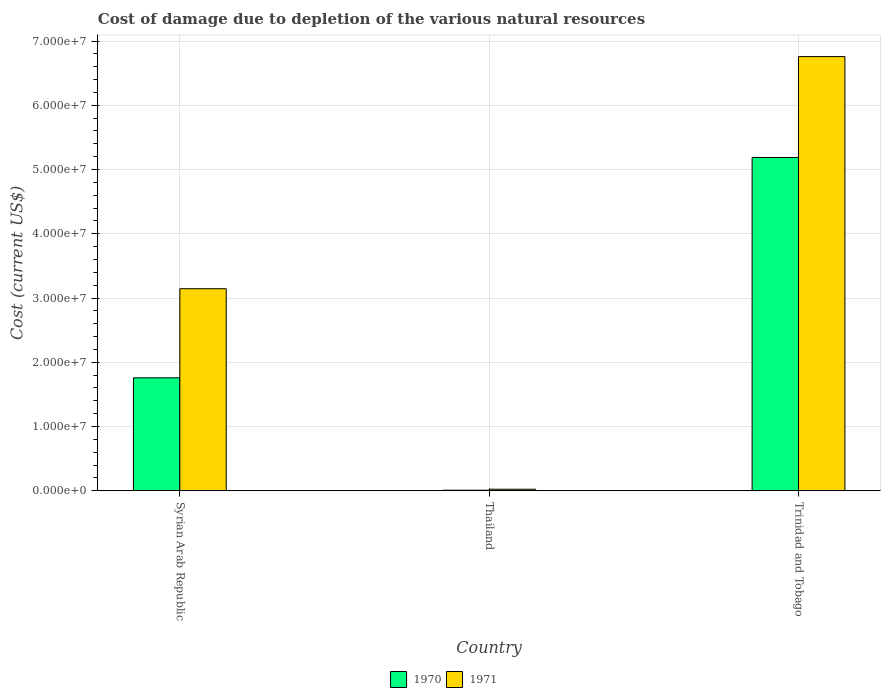How many groups of bars are there?
Your response must be concise. 3. Are the number of bars per tick equal to the number of legend labels?
Your answer should be very brief. Yes. Are the number of bars on each tick of the X-axis equal?
Make the answer very short. Yes. How many bars are there on the 3rd tick from the left?
Provide a short and direct response. 2. What is the label of the 3rd group of bars from the left?
Your answer should be very brief. Trinidad and Tobago. What is the cost of damage caused due to the depletion of various natural resources in 1971 in Syrian Arab Republic?
Offer a terse response. 3.14e+07. Across all countries, what is the maximum cost of damage caused due to the depletion of various natural resources in 1970?
Your response must be concise. 5.19e+07. Across all countries, what is the minimum cost of damage caused due to the depletion of various natural resources in 1970?
Provide a succinct answer. 9.00e+04. In which country was the cost of damage caused due to the depletion of various natural resources in 1970 maximum?
Keep it short and to the point. Trinidad and Tobago. In which country was the cost of damage caused due to the depletion of various natural resources in 1971 minimum?
Your response must be concise. Thailand. What is the total cost of damage caused due to the depletion of various natural resources in 1970 in the graph?
Keep it short and to the point. 6.96e+07. What is the difference between the cost of damage caused due to the depletion of various natural resources in 1970 in Syrian Arab Republic and that in Thailand?
Give a very brief answer. 1.75e+07. What is the difference between the cost of damage caused due to the depletion of various natural resources in 1970 in Syrian Arab Republic and the cost of damage caused due to the depletion of various natural resources in 1971 in Thailand?
Ensure brevity in your answer.  1.73e+07. What is the average cost of damage caused due to the depletion of various natural resources in 1970 per country?
Your answer should be compact. 2.32e+07. What is the difference between the cost of damage caused due to the depletion of various natural resources of/in 1970 and cost of damage caused due to the depletion of various natural resources of/in 1971 in Syrian Arab Republic?
Give a very brief answer. -1.39e+07. What is the ratio of the cost of damage caused due to the depletion of various natural resources in 1971 in Syrian Arab Republic to that in Thailand?
Ensure brevity in your answer.  129.33. What is the difference between the highest and the second highest cost of damage caused due to the depletion of various natural resources in 1971?
Offer a very short reply. -3.12e+07. What is the difference between the highest and the lowest cost of damage caused due to the depletion of various natural resources in 1970?
Provide a succinct answer. 5.18e+07. In how many countries, is the cost of damage caused due to the depletion of various natural resources in 1971 greater than the average cost of damage caused due to the depletion of various natural resources in 1971 taken over all countries?
Your answer should be very brief. 1. What does the 1st bar from the left in Thailand represents?
Your answer should be very brief. 1970. What does the 1st bar from the right in Thailand represents?
Provide a succinct answer. 1971. How many bars are there?
Offer a very short reply. 6. Are all the bars in the graph horizontal?
Provide a short and direct response. No. How many countries are there in the graph?
Your response must be concise. 3. What is the difference between two consecutive major ticks on the Y-axis?
Offer a very short reply. 1.00e+07. Are the values on the major ticks of Y-axis written in scientific E-notation?
Keep it short and to the point. Yes. Does the graph contain any zero values?
Provide a short and direct response. No. Does the graph contain grids?
Provide a short and direct response. Yes. Where does the legend appear in the graph?
Keep it short and to the point. Bottom center. How many legend labels are there?
Your answer should be very brief. 2. What is the title of the graph?
Make the answer very short. Cost of damage due to depletion of the various natural resources. Does "1999" appear as one of the legend labels in the graph?
Offer a very short reply. No. What is the label or title of the Y-axis?
Make the answer very short. Cost (current US$). What is the Cost (current US$) in 1970 in Syrian Arab Republic?
Offer a terse response. 1.76e+07. What is the Cost (current US$) in 1971 in Syrian Arab Republic?
Offer a terse response. 3.14e+07. What is the Cost (current US$) in 1970 in Thailand?
Your answer should be very brief. 9.00e+04. What is the Cost (current US$) in 1971 in Thailand?
Provide a short and direct response. 2.43e+05. What is the Cost (current US$) in 1970 in Trinidad and Tobago?
Provide a succinct answer. 5.19e+07. What is the Cost (current US$) in 1971 in Trinidad and Tobago?
Give a very brief answer. 6.76e+07. Across all countries, what is the maximum Cost (current US$) in 1970?
Provide a short and direct response. 5.19e+07. Across all countries, what is the maximum Cost (current US$) in 1971?
Make the answer very short. 6.76e+07. Across all countries, what is the minimum Cost (current US$) of 1970?
Provide a succinct answer. 9.00e+04. Across all countries, what is the minimum Cost (current US$) of 1971?
Offer a very short reply. 2.43e+05. What is the total Cost (current US$) of 1970 in the graph?
Give a very brief answer. 6.96e+07. What is the total Cost (current US$) in 1971 in the graph?
Your answer should be very brief. 9.93e+07. What is the difference between the Cost (current US$) of 1970 in Syrian Arab Republic and that in Thailand?
Give a very brief answer. 1.75e+07. What is the difference between the Cost (current US$) of 1971 in Syrian Arab Republic and that in Thailand?
Give a very brief answer. 3.12e+07. What is the difference between the Cost (current US$) of 1970 in Syrian Arab Republic and that in Trinidad and Tobago?
Offer a terse response. -3.43e+07. What is the difference between the Cost (current US$) of 1971 in Syrian Arab Republic and that in Trinidad and Tobago?
Offer a terse response. -3.61e+07. What is the difference between the Cost (current US$) in 1970 in Thailand and that in Trinidad and Tobago?
Ensure brevity in your answer.  -5.18e+07. What is the difference between the Cost (current US$) in 1971 in Thailand and that in Trinidad and Tobago?
Your answer should be compact. -6.73e+07. What is the difference between the Cost (current US$) in 1970 in Syrian Arab Republic and the Cost (current US$) in 1971 in Thailand?
Provide a succinct answer. 1.73e+07. What is the difference between the Cost (current US$) of 1970 in Syrian Arab Republic and the Cost (current US$) of 1971 in Trinidad and Tobago?
Your answer should be compact. -5.00e+07. What is the difference between the Cost (current US$) of 1970 in Thailand and the Cost (current US$) of 1971 in Trinidad and Tobago?
Make the answer very short. -6.75e+07. What is the average Cost (current US$) of 1970 per country?
Your answer should be compact. 2.32e+07. What is the average Cost (current US$) of 1971 per country?
Ensure brevity in your answer.  3.31e+07. What is the difference between the Cost (current US$) of 1970 and Cost (current US$) of 1971 in Syrian Arab Republic?
Offer a very short reply. -1.39e+07. What is the difference between the Cost (current US$) of 1970 and Cost (current US$) of 1971 in Thailand?
Provide a short and direct response. -1.53e+05. What is the difference between the Cost (current US$) of 1970 and Cost (current US$) of 1971 in Trinidad and Tobago?
Provide a short and direct response. -1.57e+07. What is the ratio of the Cost (current US$) of 1970 in Syrian Arab Republic to that in Thailand?
Provide a short and direct response. 195.44. What is the ratio of the Cost (current US$) in 1971 in Syrian Arab Republic to that in Thailand?
Your response must be concise. 129.33. What is the ratio of the Cost (current US$) of 1970 in Syrian Arab Republic to that in Trinidad and Tobago?
Provide a short and direct response. 0.34. What is the ratio of the Cost (current US$) in 1971 in Syrian Arab Republic to that in Trinidad and Tobago?
Make the answer very short. 0.47. What is the ratio of the Cost (current US$) of 1970 in Thailand to that in Trinidad and Tobago?
Ensure brevity in your answer.  0. What is the ratio of the Cost (current US$) of 1971 in Thailand to that in Trinidad and Tobago?
Give a very brief answer. 0. What is the difference between the highest and the second highest Cost (current US$) of 1970?
Provide a short and direct response. 3.43e+07. What is the difference between the highest and the second highest Cost (current US$) of 1971?
Provide a short and direct response. 3.61e+07. What is the difference between the highest and the lowest Cost (current US$) of 1970?
Offer a terse response. 5.18e+07. What is the difference between the highest and the lowest Cost (current US$) in 1971?
Ensure brevity in your answer.  6.73e+07. 